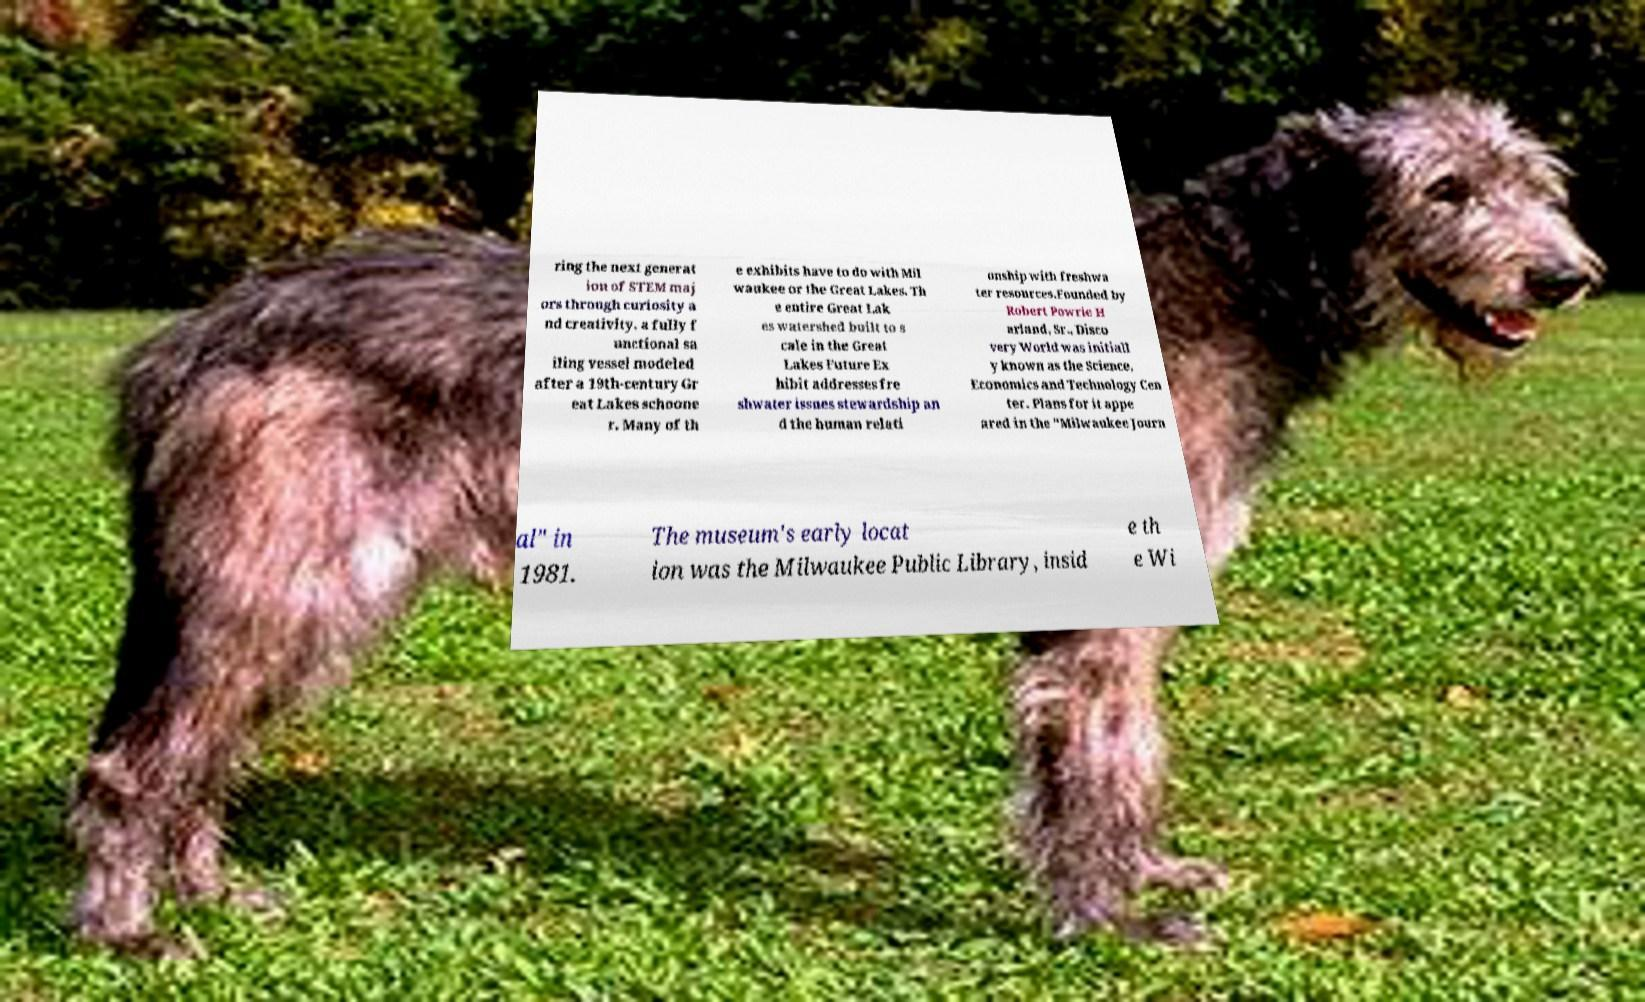Please identify and transcribe the text found in this image. ring the next generat ion of STEM maj ors through curiosity a nd creativity. a fully f unctional sa iling vessel modeled after a 19th-century Gr eat Lakes schoone r. Many of th e exhibits have to do with Mil waukee or the Great Lakes. Th e entire Great Lak es watershed built to s cale in the Great Lakes Future Ex hibit addresses fre shwater issues stewardship an d the human relati onship with freshwa ter resources.Founded by Robert Powrie H arland, Sr., Disco very World was initiall y known as the Science, Economics and Technology Cen ter. Plans for it appe ared in the "Milwaukee Journ al" in 1981. The museum's early locat ion was the Milwaukee Public Library, insid e th e Wi 